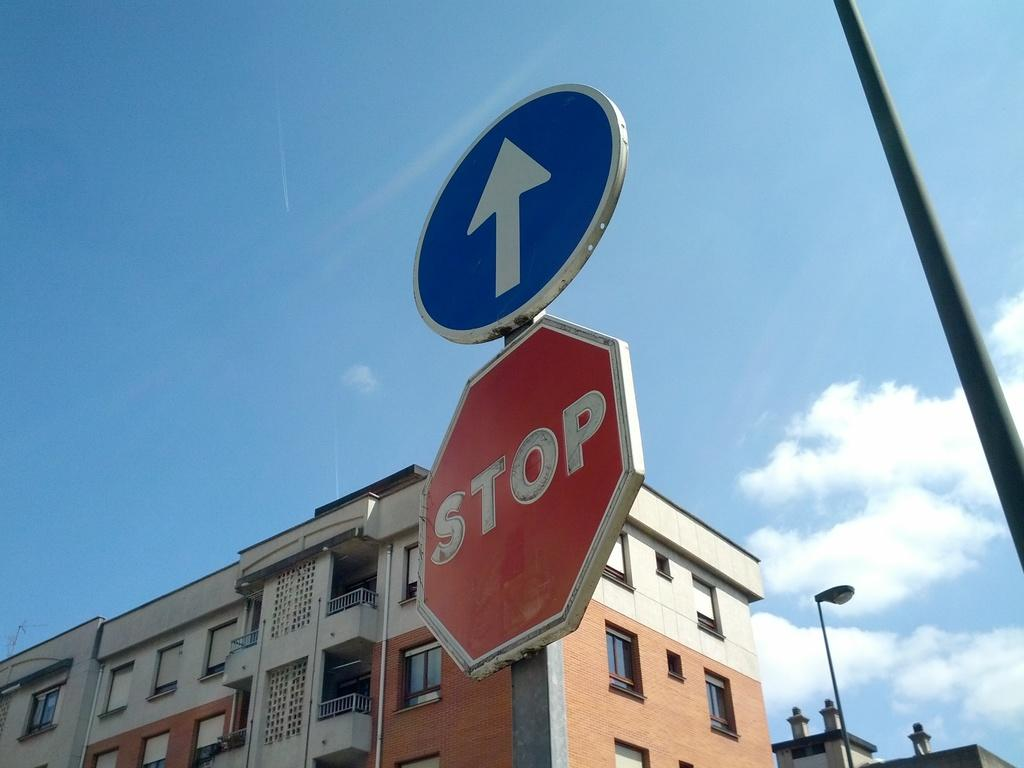<image>
Provide a brief description of the given image. the word stop is at the top of a sign 